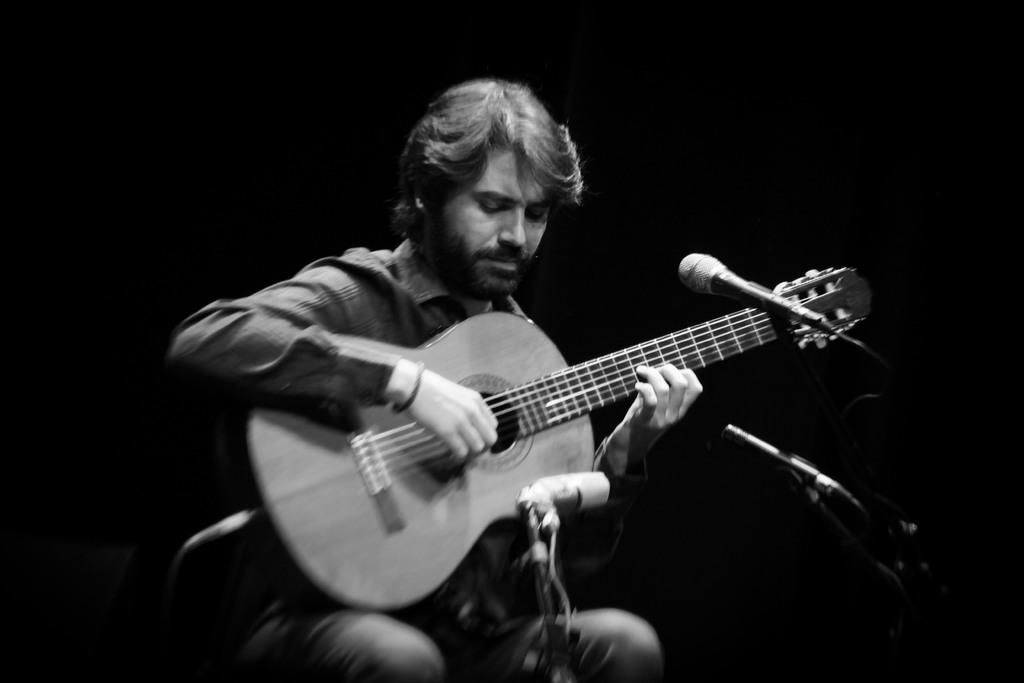Who is present in the image? There is a person in the image. What is the person doing in the image? The person is sitting and playing a guitar. What object is associated with the person's activity in the image? There is a microphone in the image. What type of grass can be seen growing around the person in the image? There is no grass visible in the image; it appears to be an indoor setting. 